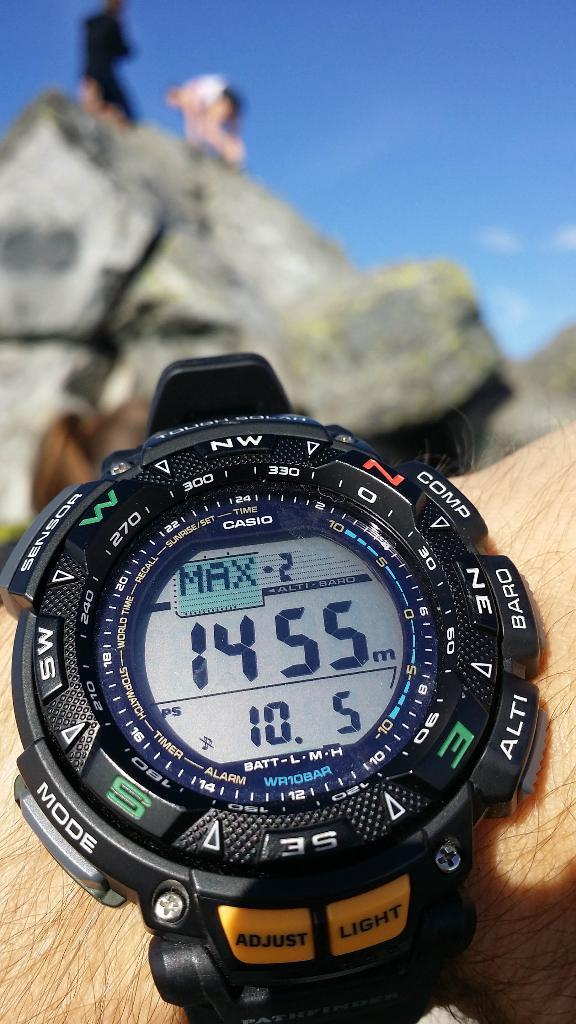<image>
Write a terse but informative summary of the picture. A black watch has buttons for adjust and light at the bottom 